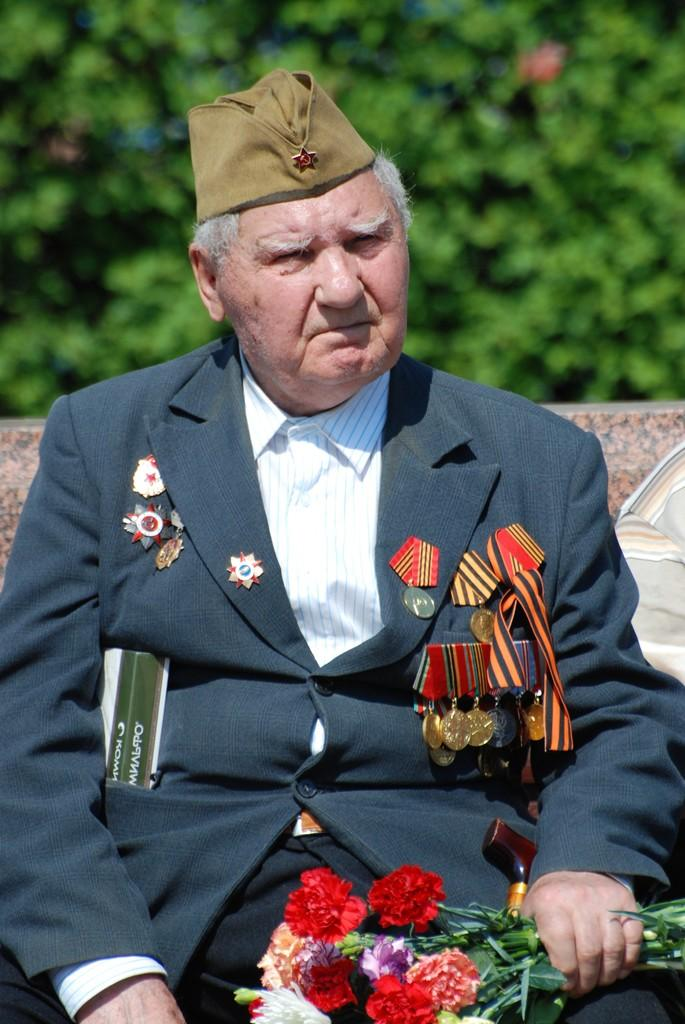Who is present in the image? There is a man in the image. What is the man doing in the image? The man is sitting. What type of clothing is the man wearing? The man is wearing a coat, a shirt, and a cap. What is the man holding in the image? The man is holding a bouquet of flowers. What can be seen in the background of the image? There are trees visible in the background of the image. What type of clouds can be seen in the image? There are no clouds visible in the image; it features a man sitting with a bouquet of flowers and trees in the background. What activity is the man participating in at the park? The image does not specify a park setting, and the man's activity is simply sitting. 